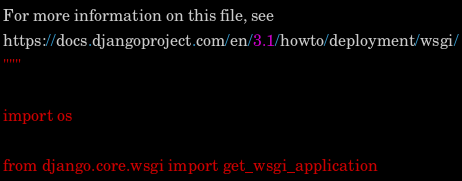Convert code to text. <code><loc_0><loc_0><loc_500><loc_500><_Python_>For more information on this file, see
https://docs.djangoproject.com/en/3.1/howto/deployment/wsgi/
"""

import os

from django.core.wsgi import get_wsgi_application
</code> 